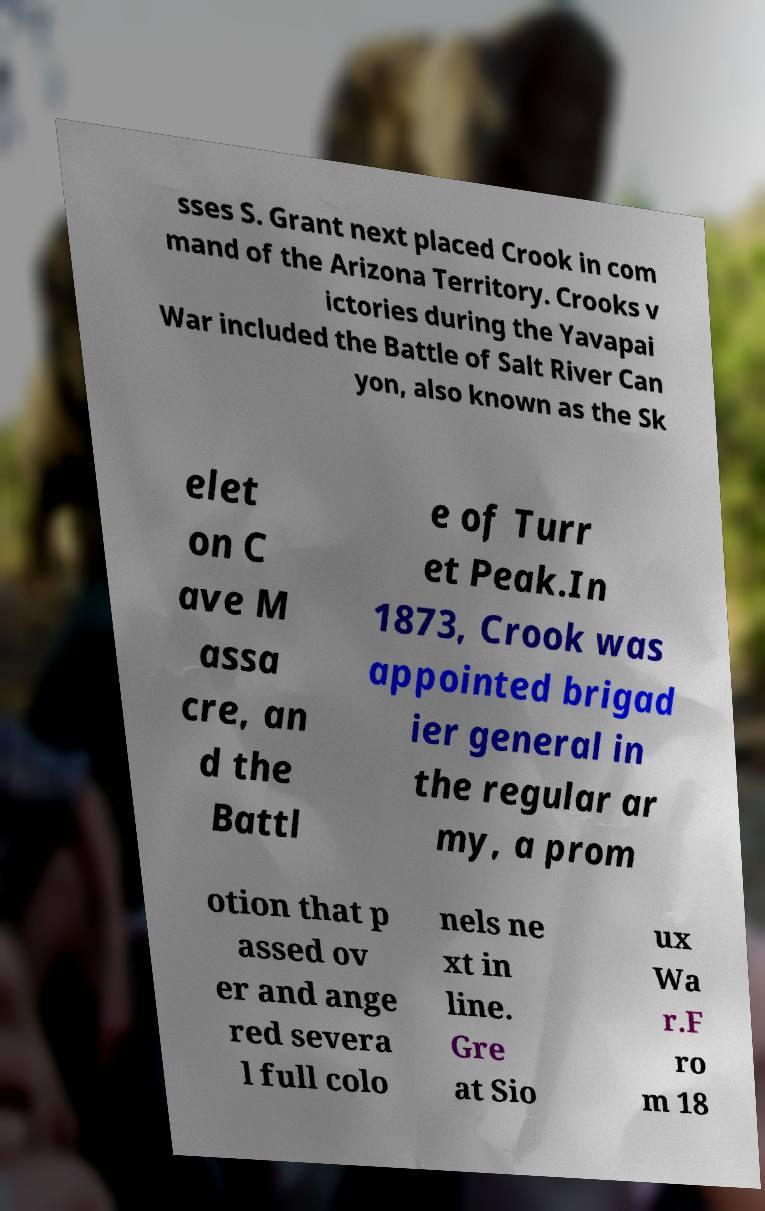Please identify and transcribe the text found in this image. sses S. Grant next placed Crook in com mand of the Arizona Territory. Crooks v ictories during the Yavapai War included the Battle of Salt River Can yon, also known as the Sk elet on C ave M assa cre, an d the Battl e of Turr et Peak.In 1873, Crook was appointed brigad ier general in the regular ar my, a prom otion that p assed ov er and ange red severa l full colo nels ne xt in line. Gre at Sio ux Wa r.F ro m 18 